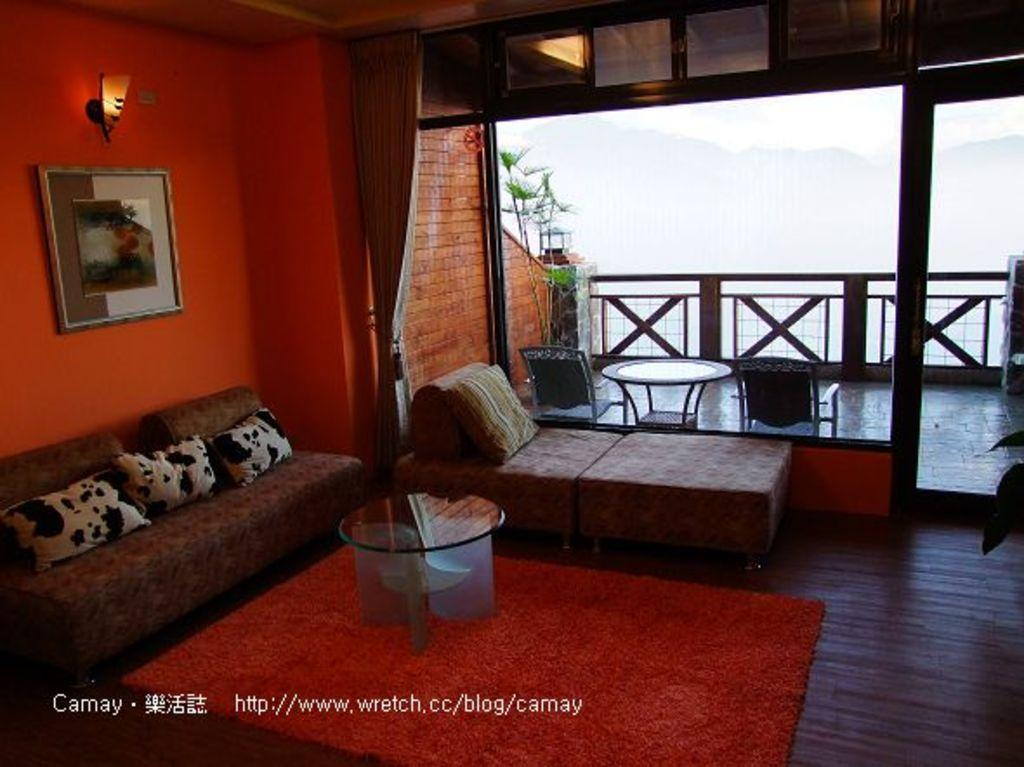What type of furniture is located on the left side of the image? There is a sofa on the left side of the image. What can be seen hanging on the wall in the image? There is a photograph on the wall. What is the source of light in the image? There is a light at the top of the image. What is in the middle of the image? There is a table in the middle of the image. What type of location is depicted in the image? The location appears to be a veranda. What type of wall is present in the image? There is a glass wall in the image. What type of rail can be seen on the sofa in the image? There is no rail present on the sofa in the image. What is the sun's position in the image? The sun is not visible in the image, only a light at the top. What is the tin used for in the image? There is no tin present in the image. 